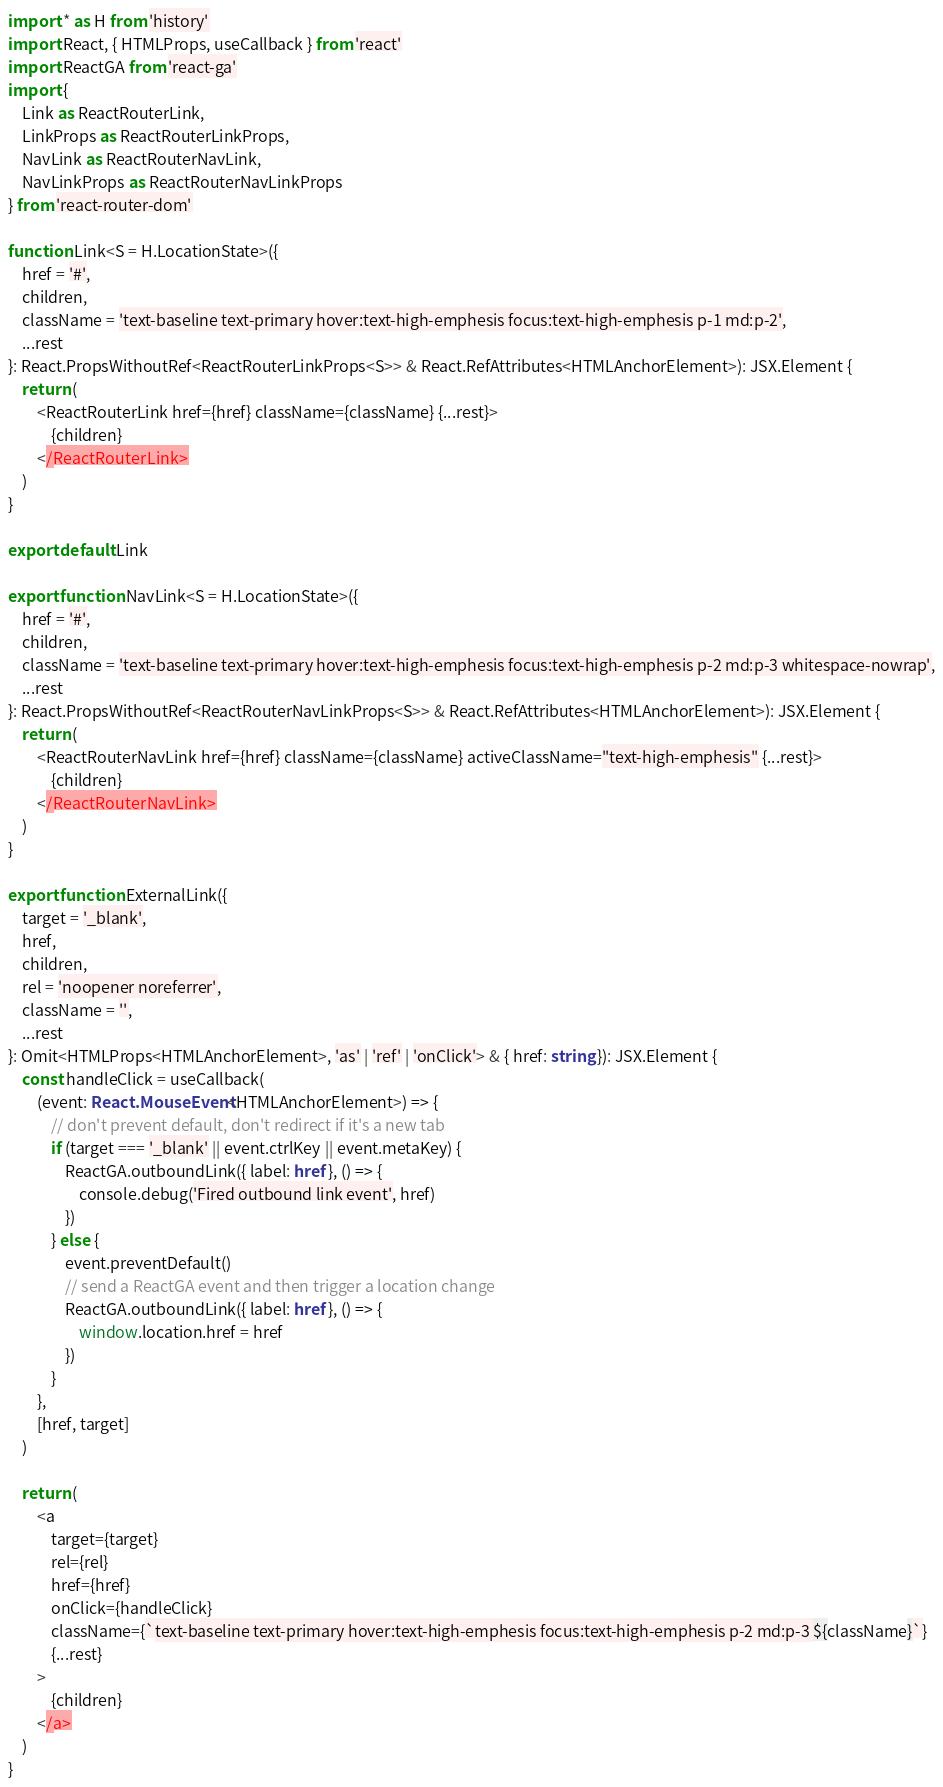<code> <loc_0><loc_0><loc_500><loc_500><_TypeScript_>import * as H from 'history'
import React, { HTMLProps, useCallback } from 'react'
import ReactGA from 'react-ga'
import {
    Link as ReactRouterLink,
    LinkProps as ReactRouterLinkProps,
    NavLink as ReactRouterNavLink,
    NavLinkProps as ReactRouterNavLinkProps
} from 'react-router-dom'

function Link<S = H.LocationState>({
    href = '#',
    children,
    className = 'text-baseline text-primary hover:text-high-emphesis focus:text-high-emphesis p-1 md:p-2',
    ...rest
}: React.PropsWithoutRef<ReactRouterLinkProps<S>> & React.RefAttributes<HTMLAnchorElement>): JSX.Element {
    return (
        <ReactRouterLink href={href} className={className} {...rest}>
            {children}
        </ReactRouterLink>
    )
}

export default Link

export function NavLink<S = H.LocationState>({
    href = '#',
    children,
    className = 'text-baseline text-primary hover:text-high-emphesis focus:text-high-emphesis p-2 md:p-3 whitespace-nowrap',
    ...rest
}: React.PropsWithoutRef<ReactRouterNavLinkProps<S>> & React.RefAttributes<HTMLAnchorElement>): JSX.Element {
    return (
        <ReactRouterNavLink href={href} className={className} activeClassName="text-high-emphesis" {...rest}>
            {children}
        </ReactRouterNavLink>
    )
}

export function ExternalLink({
    target = '_blank',
    href,
    children,
    rel = 'noopener noreferrer',
    className = '',
    ...rest
}: Omit<HTMLProps<HTMLAnchorElement>, 'as' | 'ref' | 'onClick'> & { href: string }): JSX.Element {
    const handleClick = useCallback(
        (event: React.MouseEvent<HTMLAnchorElement>) => {
            // don't prevent default, don't redirect if it's a new tab
            if (target === '_blank' || event.ctrlKey || event.metaKey) {
                ReactGA.outboundLink({ label: href }, () => {
                    console.debug('Fired outbound link event', href)
                })
            } else {
                event.preventDefault()
                // send a ReactGA event and then trigger a location change
                ReactGA.outboundLink({ label: href }, () => {
                    window.location.href = href
                })
            }
        },
        [href, target]
    )

    return (
        <a
            target={target}
            rel={rel}
            href={href}
            onClick={handleClick}
            className={`text-baseline text-primary hover:text-high-emphesis focus:text-high-emphesis p-2 md:p-3 ${className}`}
            {...rest}
        >
            {children}
        </a>
    )
}
</code> 